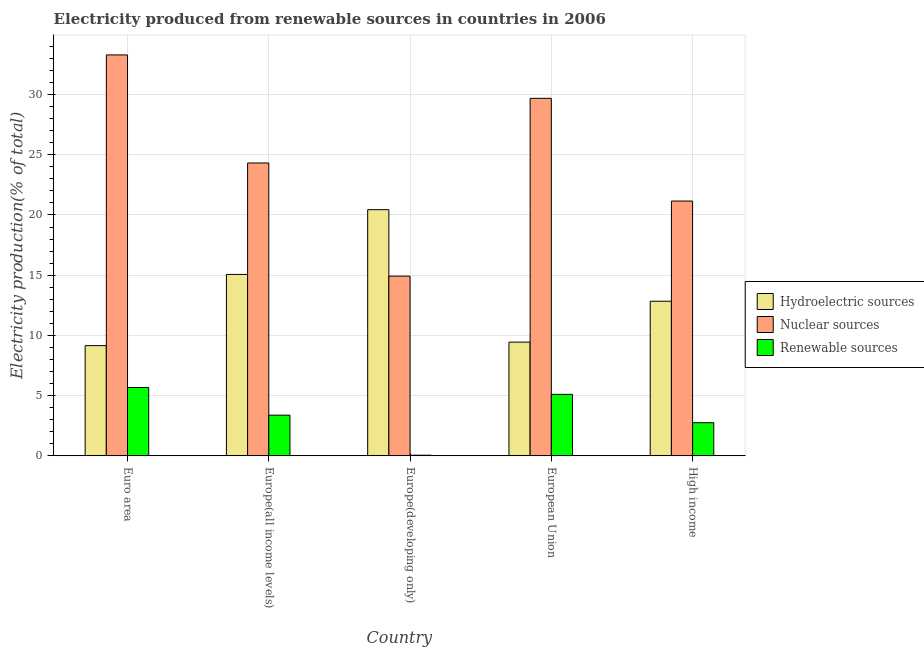How many different coloured bars are there?
Offer a terse response. 3. Are the number of bars on each tick of the X-axis equal?
Give a very brief answer. Yes. What is the label of the 2nd group of bars from the left?
Your answer should be compact. Europe(all income levels). In how many cases, is the number of bars for a given country not equal to the number of legend labels?
Your response must be concise. 0. What is the percentage of electricity produced by renewable sources in Europe(developing only)?
Offer a terse response. 0.04. Across all countries, what is the maximum percentage of electricity produced by renewable sources?
Offer a terse response. 5.67. Across all countries, what is the minimum percentage of electricity produced by hydroelectric sources?
Provide a succinct answer. 9.14. In which country was the percentage of electricity produced by hydroelectric sources maximum?
Provide a short and direct response. Europe(developing only). In which country was the percentage of electricity produced by renewable sources minimum?
Your response must be concise. Europe(developing only). What is the total percentage of electricity produced by renewable sources in the graph?
Give a very brief answer. 16.92. What is the difference between the percentage of electricity produced by hydroelectric sources in Europe(all income levels) and that in High income?
Give a very brief answer. 2.23. What is the difference between the percentage of electricity produced by nuclear sources in European Union and the percentage of electricity produced by renewable sources in High income?
Provide a succinct answer. 26.95. What is the average percentage of electricity produced by nuclear sources per country?
Your answer should be compact. 24.68. What is the difference between the percentage of electricity produced by hydroelectric sources and percentage of electricity produced by nuclear sources in Europe(all income levels)?
Provide a succinct answer. -9.26. What is the ratio of the percentage of electricity produced by renewable sources in Euro area to that in Europe(developing only)?
Provide a succinct answer. 131.88. Is the difference between the percentage of electricity produced by hydroelectric sources in Europe(all income levels) and Europe(developing only) greater than the difference between the percentage of electricity produced by nuclear sources in Europe(all income levels) and Europe(developing only)?
Your response must be concise. No. What is the difference between the highest and the second highest percentage of electricity produced by hydroelectric sources?
Provide a short and direct response. 5.38. What is the difference between the highest and the lowest percentage of electricity produced by renewable sources?
Your answer should be compact. 5.63. What does the 3rd bar from the left in Europe(developing only) represents?
Your answer should be very brief. Renewable sources. What does the 2nd bar from the right in Europe(developing only) represents?
Provide a succinct answer. Nuclear sources. Is it the case that in every country, the sum of the percentage of electricity produced by hydroelectric sources and percentage of electricity produced by nuclear sources is greater than the percentage of electricity produced by renewable sources?
Provide a succinct answer. Yes. How many bars are there?
Offer a terse response. 15. Are the values on the major ticks of Y-axis written in scientific E-notation?
Offer a terse response. No. Does the graph contain any zero values?
Your answer should be compact. No. How many legend labels are there?
Offer a terse response. 3. What is the title of the graph?
Your answer should be very brief. Electricity produced from renewable sources in countries in 2006. Does "New Zealand" appear as one of the legend labels in the graph?
Ensure brevity in your answer.  No. What is the Electricity production(% of total) in Hydroelectric sources in Euro area?
Offer a terse response. 9.14. What is the Electricity production(% of total) in Nuclear sources in Euro area?
Offer a terse response. 33.3. What is the Electricity production(% of total) of Renewable sources in Euro area?
Offer a very short reply. 5.67. What is the Electricity production(% of total) in Hydroelectric sources in Europe(all income levels)?
Offer a very short reply. 15.06. What is the Electricity production(% of total) of Nuclear sources in Europe(all income levels)?
Provide a succinct answer. 24.32. What is the Electricity production(% of total) in Renewable sources in Europe(all income levels)?
Your answer should be very brief. 3.37. What is the Electricity production(% of total) of Hydroelectric sources in Europe(developing only)?
Give a very brief answer. 20.44. What is the Electricity production(% of total) of Nuclear sources in Europe(developing only)?
Ensure brevity in your answer.  14.92. What is the Electricity production(% of total) in Renewable sources in Europe(developing only)?
Give a very brief answer. 0.04. What is the Electricity production(% of total) of Hydroelectric sources in European Union?
Offer a terse response. 9.44. What is the Electricity production(% of total) in Nuclear sources in European Union?
Ensure brevity in your answer.  29.69. What is the Electricity production(% of total) in Renewable sources in European Union?
Give a very brief answer. 5.1. What is the Electricity production(% of total) of Hydroelectric sources in High income?
Offer a very short reply. 12.83. What is the Electricity production(% of total) in Nuclear sources in High income?
Offer a terse response. 21.16. What is the Electricity production(% of total) in Renewable sources in High income?
Provide a short and direct response. 2.74. Across all countries, what is the maximum Electricity production(% of total) of Hydroelectric sources?
Make the answer very short. 20.44. Across all countries, what is the maximum Electricity production(% of total) in Nuclear sources?
Your answer should be compact. 33.3. Across all countries, what is the maximum Electricity production(% of total) of Renewable sources?
Offer a terse response. 5.67. Across all countries, what is the minimum Electricity production(% of total) of Hydroelectric sources?
Provide a succinct answer. 9.14. Across all countries, what is the minimum Electricity production(% of total) in Nuclear sources?
Offer a terse response. 14.92. Across all countries, what is the minimum Electricity production(% of total) in Renewable sources?
Ensure brevity in your answer.  0.04. What is the total Electricity production(% of total) of Hydroelectric sources in the graph?
Offer a very short reply. 66.92. What is the total Electricity production(% of total) in Nuclear sources in the graph?
Offer a terse response. 123.38. What is the total Electricity production(% of total) of Renewable sources in the graph?
Your answer should be compact. 16.92. What is the difference between the Electricity production(% of total) in Hydroelectric sources in Euro area and that in Europe(all income levels)?
Your response must be concise. -5.92. What is the difference between the Electricity production(% of total) in Nuclear sources in Euro area and that in Europe(all income levels)?
Give a very brief answer. 8.98. What is the difference between the Electricity production(% of total) in Renewable sources in Euro area and that in Europe(all income levels)?
Offer a terse response. 2.3. What is the difference between the Electricity production(% of total) in Hydroelectric sources in Euro area and that in Europe(developing only)?
Your answer should be very brief. -11.3. What is the difference between the Electricity production(% of total) in Nuclear sources in Euro area and that in Europe(developing only)?
Your answer should be very brief. 18.38. What is the difference between the Electricity production(% of total) of Renewable sources in Euro area and that in Europe(developing only)?
Ensure brevity in your answer.  5.63. What is the difference between the Electricity production(% of total) in Hydroelectric sources in Euro area and that in European Union?
Ensure brevity in your answer.  -0.29. What is the difference between the Electricity production(% of total) in Nuclear sources in Euro area and that in European Union?
Provide a succinct answer. 3.61. What is the difference between the Electricity production(% of total) of Renewable sources in Euro area and that in European Union?
Your response must be concise. 0.57. What is the difference between the Electricity production(% of total) in Hydroelectric sources in Euro area and that in High income?
Make the answer very short. -3.69. What is the difference between the Electricity production(% of total) in Nuclear sources in Euro area and that in High income?
Give a very brief answer. 12.14. What is the difference between the Electricity production(% of total) in Renewable sources in Euro area and that in High income?
Offer a very short reply. 2.93. What is the difference between the Electricity production(% of total) in Hydroelectric sources in Europe(all income levels) and that in Europe(developing only)?
Your answer should be compact. -5.38. What is the difference between the Electricity production(% of total) in Nuclear sources in Europe(all income levels) and that in Europe(developing only)?
Provide a succinct answer. 9.4. What is the difference between the Electricity production(% of total) in Renewable sources in Europe(all income levels) and that in Europe(developing only)?
Your answer should be compact. 3.33. What is the difference between the Electricity production(% of total) of Hydroelectric sources in Europe(all income levels) and that in European Union?
Offer a terse response. 5.62. What is the difference between the Electricity production(% of total) of Nuclear sources in Europe(all income levels) and that in European Union?
Keep it short and to the point. -5.37. What is the difference between the Electricity production(% of total) in Renewable sources in Europe(all income levels) and that in European Union?
Offer a terse response. -1.73. What is the difference between the Electricity production(% of total) in Hydroelectric sources in Europe(all income levels) and that in High income?
Make the answer very short. 2.23. What is the difference between the Electricity production(% of total) of Nuclear sources in Europe(all income levels) and that in High income?
Offer a terse response. 3.16. What is the difference between the Electricity production(% of total) in Renewable sources in Europe(all income levels) and that in High income?
Provide a short and direct response. 0.63. What is the difference between the Electricity production(% of total) in Hydroelectric sources in Europe(developing only) and that in European Union?
Give a very brief answer. 11. What is the difference between the Electricity production(% of total) of Nuclear sources in Europe(developing only) and that in European Union?
Your answer should be compact. -14.77. What is the difference between the Electricity production(% of total) in Renewable sources in Europe(developing only) and that in European Union?
Make the answer very short. -5.05. What is the difference between the Electricity production(% of total) of Hydroelectric sources in Europe(developing only) and that in High income?
Ensure brevity in your answer.  7.61. What is the difference between the Electricity production(% of total) of Nuclear sources in Europe(developing only) and that in High income?
Provide a short and direct response. -6.24. What is the difference between the Electricity production(% of total) of Renewable sources in Europe(developing only) and that in High income?
Offer a terse response. -2.7. What is the difference between the Electricity production(% of total) of Hydroelectric sources in European Union and that in High income?
Provide a short and direct response. -3.4. What is the difference between the Electricity production(% of total) in Nuclear sources in European Union and that in High income?
Keep it short and to the point. 8.53. What is the difference between the Electricity production(% of total) of Renewable sources in European Union and that in High income?
Keep it short and to the point. 2.35. What is the difference between the Electricity production(% of total) in Hydroelectric sources in Euro area and the Electricity production(% of total) in Nuclear sources in Europe(all income levels)?
Your response must be concise. -15.17. What is the difference between the Electricity production(% of total) in Hydroelectric sources in Euro area and the Electricity production(% of total) in Renewable sources in Europe(all income levels)?
Offer a very short reply. 5.77. What is the difference between the Electricity production(% of total) in Nuclear sources in Euro area and the Electricity production(% of total) in Renewable sources in Europe(all income levels)?
Provide a short and direct response. 29.93. What is the difference between the Electricity production(% of total) of Hydroelectric sources in Euro area and the Electricity production(% of total) of Nuclear sources in Europe(developing only)?
Provide a short and direct response. -5.78. What is the difference between the Electricity production(% of total) in Hydroelectric sources in Euro area and the Electricity production(% of total) in Renewable sources in Europe(developing only)?
Ensure brevity in your answer.  9.1. What is the difference between the Electricity production(% of total) in Nuclear sources in Euro area and the Electricity production(% of total) in Renewable sources in Europe(developing only)?
Provide a succinct answer. 33.25. What is the difference between the Electricity production(% of total) in Hydroelectric sources in Euro area and the Electricity production(% of total) in Nuclear sources in European Union?
Provide a succinct answer. -20.54. What is the difference between the Electricity production(% of total) of Hydroelectric sources in Euro area and the Electricity production(% of total) of Renewable sources in European Union?
Your response must be concise. 4.05. What is the difference between the Electricity production(% of total) of Nuclear sources in Euro area and the Electricity production(% of total) of Renewable sources in European Union?
Provide a short and direct response. 28.2. What is the difference between the Electricity production(% of total) of Hydroelectric sources in Euro area and the Electricity production(% of total) of Nuclear sources in High income?
Your response must be concise. -12.01. What is the difference between the Electricity production(% of total) in Hydroelectric sources in Euro area and the Electricity production(% of total) in Renewable sources in High income?
Give a very brief answer. 6.4. What is the difference between the Electricity production(% of total) of Nuclear sources in Euro area and the Electricity production(% of total) of Renewable sources in High income?
Keep it short and to the point. 30.55. What is the difference between the Electricity production(% of total) of Hydroelectric sources in Europe(all income levels) and the Electricity production(% of total) of Nuclear sources in Europe(developing only)?
Your answer should be compact. 0.14. What is the difference between the Electricity production(% of total) in Hydroelectric sources in Europe(all income levels) and the Electricity production(% of total) in Renewable sources in Europe(developing only)?
Offer a terse response. 15.02. What is the difference between the Electricity production(% of total) in Nuclear sources in Europe(all income levels) and the Electricity production(% of total) in Renewable sources in Europe(developing only)?
Provide a succinct answer. 24.27. What is the difference between the Electricity production(% of total) in Hydroelectric sources in Europe(all income levels) and the Electricity production(% of total) in Nuclear sources in European Union?
Provide a succinct answer. -14.63. What is the difference between the Electricity production(% of total) of Hydroelectric sources in Europe(all income levels) and the Electricity production(% of total) of Renewable sources in European Union?
Your response must be concise. 9.96. What is the difference between the Electricity production(% of total) in Nuclear sources in Europe(all income levels) and the Electricity production(% of total) in Renewable sources in European Union?
Offer a very short reply. 19.22. What is the difference between the Electricity production(% of total) of Hydroelectric sources in Europe(all income levels) and the Electricity production(% of total) of Nuclear sources in High income?
Ensure brevity in your answer.  -6.09. What is the difference between the Electricity production(% of total) in Hydroelectric sources in Europe(all income levels) and the Electricity production(% of total) in Renewable sources in High income?
Provide a short and direct response. 12.32. What is the difference between the Electricity production(% of total) in Nuclear sources in Europe(all income levels) and the Electricity production(% of total) in Renewable sources in High income?
Your answer should be very brief. 21.57. What is the difference between the Electricity production(% of total) of Hydroelectric sources in Europe(developing only) and the Electricity production(% of total) of Nuclear sources in European Union?
Your answer should be very brief. -9.25. What is the difference between the Electricity production(% of total) of Hydroelectric sources in Europe(developing only) and the Electricity production(% of total) of Renewable sources in European Union?
Keep it short and to the point. 15.35. What is the difference between the Electricity production(% of total) in Nuclear sources in Europe(developing only) and the Electricity production(% of total) in Renewable sources in European Union?
Your answer should be very brief. 9.82. What is the difference between the Electricity production(% of total) in Hydroelectric sources in Europe(developing only) and the Electricity production(% of total) in Nuclear sources in High income?
Provide a succinct answer. -0.71. What is the difference between the Electricity production(% of total) of Hydroelectric sources in Europe(developing only) and the Electricity production(% of total) of Renewable sources in High income?
Your answer should be compact. 17.7. What is the difference between the Electricity production(% of total) in Nuclear sources in Europe(developing only) and the Electricity production(% of total) in Renewable sources in High income?
Your answer should be compact. 12.18. What is the difference between the Electricity production(% of total) in Hydroelectric sources in European Union and the Electricity production(% of total) in Nuclear sources in High income?
Make the answer very short. -11.72. What is the difference between the Electricity production(% of total) of Hydroelectric sources in European Union and the Electricity production(% of total) of Renewable sources in High income?
Provide a succinct answer. 6.7. What is the difference between the Electricity production(% of total) in Nuclear sources in European Union and the Electricity production(% of total) in Renewable sources in High income?
Your answer should be compact. 26.95. What is the average Electricity production(% of total) of Hydroelectric sources per country?
Provide a succinct answer. 13.38. What is the average Electricity production(% of total) of Nuclear sources per country?
Offer a terse response. 24.68. What is the average Electricity production(% of total) in Renewable sources per country?
Give a very brief answer. 3.38. What is the difference between the Electricity production(% of total) in Hydroelectric sources and Electricity production(% of total) in Nuclear sources in Euro area?
Your response must be concise. -24.15. What is the difference between the Electricity production(% of total) in Hydroelectric sources and Electricity production(% of total) in Renewable sources in Euro area?
Make the answer very short. 3.47. What is the difference between the Electricity production(% of total) of Nuclear sources and Electricity production(% of total) of Renewable sources in Euro area?
Ensure brevity in your answer.  27.63. What is the difference between the Electricity production(% of total) of Hydroelectric sources and Electricity production(% of total) of Nuclear sources in Europe(all income levels)?
Provide a short and direct response. -9.26. What is the difference between the Electricity production(% of total) in Hydroelectric sources and Electricity production(% of total) in Renewable sources in Europe(all income levels)?
Your answer should be compact. 11.69. What is the difference between the Electricity production(% of total) in Nuclear sources and Electricity production(% of total) in Renewable sources in Europe(all income levels)?
Your response must be concise. 20.95. What is the difference between the Electricity production(% of total) of Hydroelectric sources and Electricity production(% of total) of Nuclear sources in Europe(developing only)?
Your response must be concise. 5.52. What is the difference between the Electricity production(% of total) of Hydroelectric sources and Electricity production(% of total) of Renewable sources in Europe(developing only)?
Your response must be concise. 20.4. What is the difference between the Electricity production(% of total) of Nuclear sources and Electricity production(% of total) of Renewable sources in Europe(developing only)?
Your answer should be very brief. 14.88. What is the difference between the Electricity production(% of total) of Hydroelectric sources and Electricity production(% of total) of Nuclear sources in European Union?
Ensure brevity in your answer.  -20.25. What is the difference between the Electricity production(% of total) in Hydroelectric sources and Electricity production(% of total) in Renewable sources in European Union?
Ensure brevity in your answer.  4.34. What is the difference between the Electricity production(% of total) in Nuclear sources and Electricity production(% of total) in Renewable sources in European Union?
Provide a short and direct response. 24.59. What is the difference between the Electricity production(% of total) of Hydroelectric sources and Electricity production(% of total) of Nuclear sources in High income?
Your answer should be compact. -8.32. What is the difference between the Electricity production(% of total) in Hydroelectric sources and Electricity production(% of total) in Renewable sources in High income?
Offer a terse response. 10.09. What is the difference between the Electricity production(% of total) in Nuclear sources and Electricity production(% of total) in Renewable sources in High income?
Your response must be concise. 18.41. What is the ratio of the Electricity production(% of total) in Hydroelectric sources in Euro area to that in Europe(all income levels)?
Give a very brief answer. 0.61. What is the ratio of the Electricity production(% of total) in Nuclear sources in Euro area to that in Europe(all income levels)?
Your answer should be compact. 1.37. What is the ratio of the Electricity production(% of total) of Renewable sources in Euro area to that in Europe(all income levels)?
Your response must be concise. 1.68. What is the ratio of the Electricity production(% of total) of Hydroelectric sources in Euro area to that in Europe(developing only)?
Offer a very short reply. 0.45. What is the ratio of the Electricity production(% of total) of Nuclear sources in Euro area to that in Europe(developing only)?
Offer a very short reply. 2.23. What is the ratio of the Electricity production(% of total) of Renewable sources in Euro area to that in Europe(developing only)?
Your answer should be very brief. 131.88. What is the ratio of the Electricity production(% of total) of Hydroelectric sources in Euro area to that in European Union?
Your answer should be very brief. 0.97. What is the ratio of the Electricity production(% of total) in Nuclear sources in Euro area to that in European Union?
Provide a succinct answer. 1.12. What is the ratio of the Electricity production(% of total) in Renewable sources in Euro area to that in European Union?
Make the answer very short. 1.11. What is the ratio of the Electricity production(% of total) in Hydroelectric sources in Euro area to that in High income?
Your answer should be very brief. 0.71. What is the ratio of the Electricity production(% of total) of Nuclear sources in Euro area to that in High income?
Your answer should be very brief. 1.57. What is the ratio of the Electricity production(% of total) in Renewable sources in Euro area to that in High income?
Your response must be concise. 2.07. What is the ratio of the Electricity production(% of total) of Hydroelectric sources in Europe(all income levels) to that in Europe(developing only)?
Your answer should be very brief. 0.74. What is the ratio of the Electricity production(% of total) in Nuclear sources in Europe(all income levels) to that in Europe(developing only)?
Keep it short and to the point. 1.63. What is the ratio of the Electricity production(% of total) of Renewable sources in Europe(all income levels) to that in Europe(developing only)?
Offer a very short reply. 78.38. What is the ratio of the Electricity production(% of total) in Hydroelectric sources in Europe(all income levels) to that in European Union?
Your answer should be very brief. 1.6. What is the ratio of the Electricity production(% of total) of Nuclear sources in Europe(all income levels) to that in European Union?
Your answer should be very brief. 0.82. What is the ratio of the Electricity production(% of total) of Renewable sources in Europe(all income levels) to that in European Union?
Ensure brevity in your answer.  0.66. What is the ratio of the Electricity production(% of total) of Hydroelectric sources in Europe(all income levels) to that in High income?
Offer a terse response. 1.17. What is the ratio of the Electricity production(% of total) in Nuclear sources in Europe(all income levels) to that in High income?
Make the answer very short. 1.15. What is the ratio of the Electricity production(% of total) in Renewable sources in Europe(all income levels) to that in High income?
Give a very brief answer. 1.23. What is the ratio of the Electricity production(% of total) of Hydroelectric sources in Europe(developing only) to that in European Union?
Your answer should be very brief. 2.17. What is the ratio of the Electricity production(% of total) in Nuclear sources in Europe(developing only) to that in European Union?
Provide a short and direct response. 0.5. What is the ratio of the Electricity production(% of total) in Renewable sources in Europe(developing only) to that in European Union?
Offer a very short reply. 0.01. What is the ratio of the Electricity production(% of total) of Hydroelectric sources in Europe(developing only) to that in High income?
Provide a short and direct response. 1.59. What is the ratio of the Electricity production(% of total) of Nuclear sources in Europe(developing only) to that in High income?
Your answer should be compact. 0.71. What is the ratio of the Electricity production(% of total) of Renewable sources in Europe(developing only) to that in High income?
Your response must be concise. 0.02. What is the ratio of the Electricity production(% of total) in Hydroelectric sources in European Union to that in High income?
Give a very brief answer. 0.74. What is the ratio of the Electricity production(% of total) in Nuclear sources in European Union to that in High income?
Give a very brief answer. 1.4. What is the ratio of the Electricity production(% of total) in Renewable sources in European Union to that in High income?
Give a very brief answer. 1.86. What is the difference between the highest and the second highest Electricity production(% of total) of Hydroelectric sources?
Give a very brief answer. 5.38. What is the difference between the highest and the second highest Electricity production(% of total) of Nuclear sources?
Provide a succinct answer. 3.61. What is the difference between the highest and the second highest Electricity production(% of total) in Renewable sources?
Provide a succinct answer. 0.57. What is the difference between the highest and the lowest Electricity production(% of total) of Hydroelectric sources?
Give a very brief answer. 11.3. What is the difference between the highest and the lowest Electricity production(% of total) in Nuclear sources?
Your answer should be compact. 18.38. What is the difference between the highest and the lowest Electricity production(% of total) of Renewable sources?
Your answer should be compact. 5.63. 